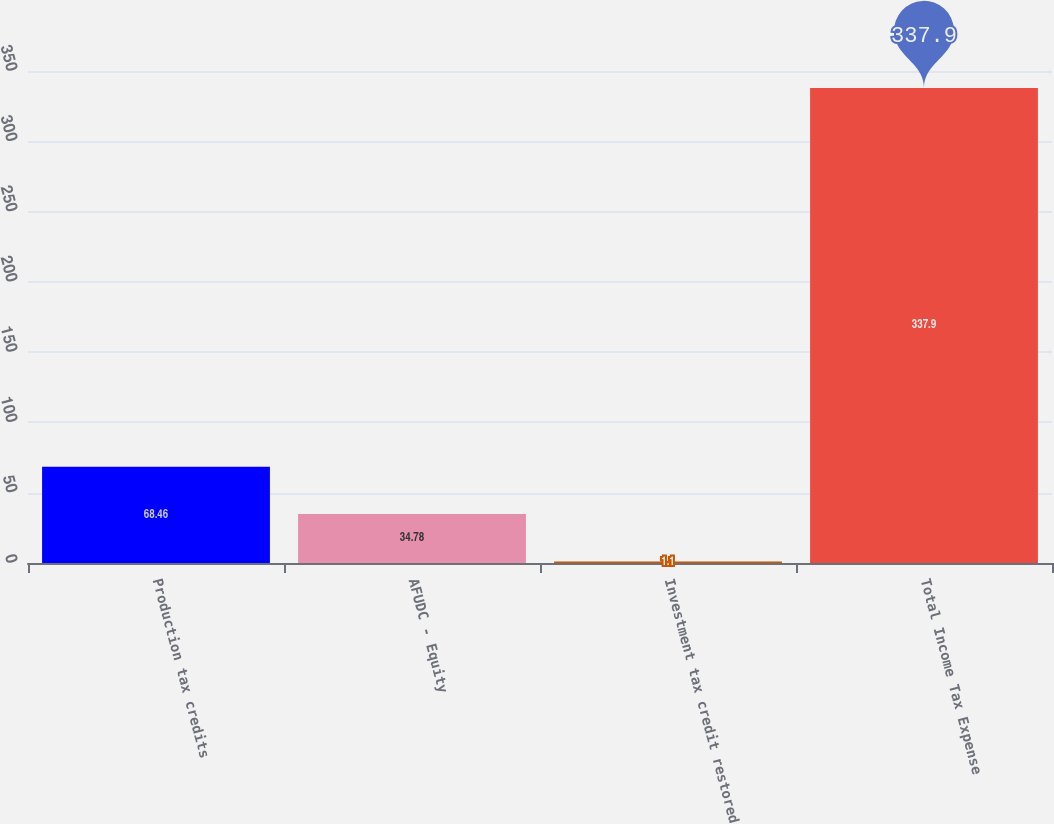Convert chart to OTSL. <chart><loc_0><loc_0><loc_500><loc_500><bar_chart><fcel>Production tax credits<fcel>AFUDC - Equity<fcel>Investment tax credit restored<fcel>Total Income Tax Expense<nl><fcel>68.46<fcel>34.78<fcel>1.1<fcel>337.9<nl></chart> 